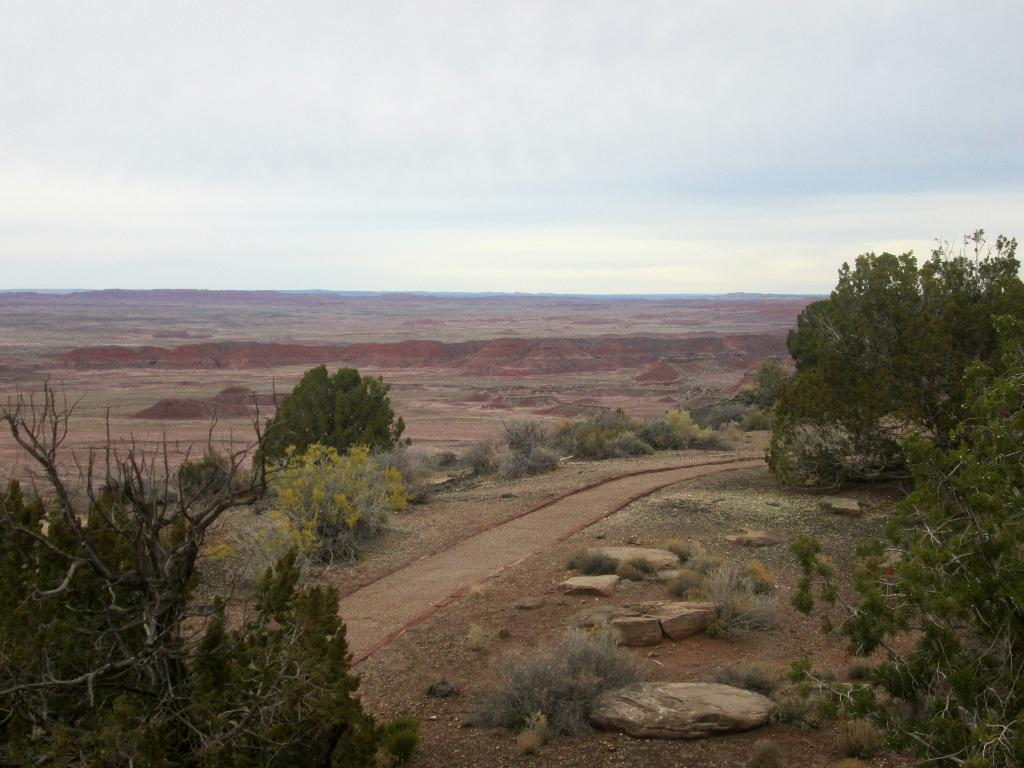What type of vegetation is visible at the front of the image? There are trees in front of the image. What type of natural feature can be seen in the image? There are rocks in the image. What is the main feature in the center of the image? There is a road in the center of the image. What type of flora is present in the image? There are plants in the image. What type of landscape can be seen in the background of the image? There are mountains in the background of the image. What is visible in the sky in the background of the image? The sky is visible in the background of the image. Can you tell me how many brothers are walking downtown in the image? There are no brothers or downtown area present in the image. Are there any dinosaurs visible in the image? There are no dinosaurs present in the image. 